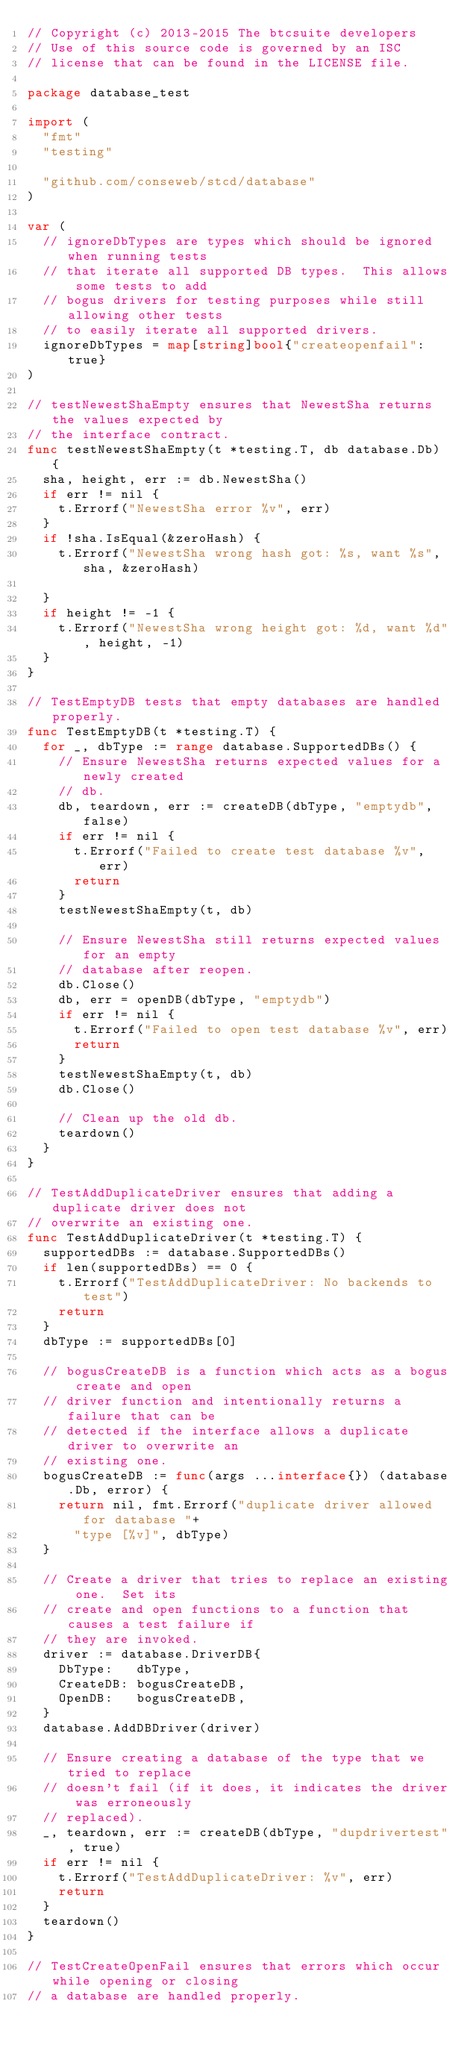<code> <loc_0><loc_0><loc_500><loc_500><_Go_>// Copyright (c) 2013-2015 The btcsuite developers
// Use of this source code is governed by an ISC
// license that can be found in the LICENSE file.

package database_test

import (
	"fmt"
	"testing"

	"github.com/conseweb/stcd/database"
)

var (
	// ignoreDbTypes are types which should be ignored when running tests
	// that iterate all supported DB types.  This allows some tests to add
	// bogus drivers for testing purposes while still allowing other tests
	// to easily iterate all supported drivers.
	ignoreDbTypes = map[string]bool{"createopenfail": true}
)

// testNewestShaEmpty ensures that NewestSha returns the values expected by
// the interface contract.
func testNewestShaEmpty(t *testing.T, db database.Db) {
	sha, height, err := db.NewestSha()
	if err != nil {
		t.Errorf("NewestSha error %v", err)
	}
	if !sha.IsEqual(&zeroHash) {
		t.Errorf("NewestSha wrong hash got: %s, want %s", sha, &zeroHash)

	}
	if height != -1 {
		t.Errorf("NewestSha wrong height got: %d, want %d", height, -1)
	}
}

// TestEmptyDB tests that empty databases are handled properly.
func TestEmptyDB(t *testing.T) {
	for _, dbType := range database.SupportedDBs() {
		// Ensure NewestSha returns expected values for a newly created
		// db.
		db, teardown, err := createDB(dbType, "emptydb", false)
		if err != nil {
			t.Errorf("Failed to create test database %v", err)
			return
		}
		testNewestShaEmpty(t, db)

		// Ensure NewestSha still returns expected values for an empty
		// database after reopen.
		db.Close()
		db, err = openDB(dbType, "emptydb")
		if err != nil {
			t.Errorf("Failed to open test database %v", err)
			return
		}
		testNewestShaEmpty(t, db)
		db.Close()

		// Clean up the old db.
		teardown()
	}
}

// TestAddDuplicateDriver ensures that adding a duplicate driver does not
// overwrite an existing one.
func TestAddDuplicateDriver(t *testing.T) {
	supportedDBs := database.SupportedDBs()
	if len(supportedDBs) == 0 {
		t.Errorf("TestAddDuplicateDriver: No backends to test")
		return
	}
	dbType := supportedDBs[0]

	// bogusCreateDB is a function which acts as a bogus create and open
	// driver function and intentionally returns a failure that can be
	// detected if the interface allows a duplicate driver to overwrite an
	// existing one.
	bogusCreateDB := func(args ...interface{}) (database.Db, error) {
		return nil, fmt.Errorf("duplicate driver allowed for database "+
			"type [%v]", dbType)
	}

	// Create a driver that tries to replace an existing one.  Set its
	// create and open functions to a function that causes a test failure if
	// they are invoked.
	driver := database.DriverDB{
		DbType:   dbType,
		CreateDB: bogusCreateDB,
		OpenDB:   bogusCreateDB,
	}
	database.AddDBDriver(driver)

	// Ensure creating a database of the type that we tried to replace
	// doesn't fail (if it does, it indicates the driver was erroneously
	// replaced).
	_, teardown, err := createDB(dbType, "dupdrivertest", true)
	if err != nil {
		t.Errorf("TestAddDuplicateDriver: %v", err)
		return
	}
	teardown()
}

// TestCreateOpenFail ensures that errors which occur while opening or closing
// a database are handled properly.</code> 